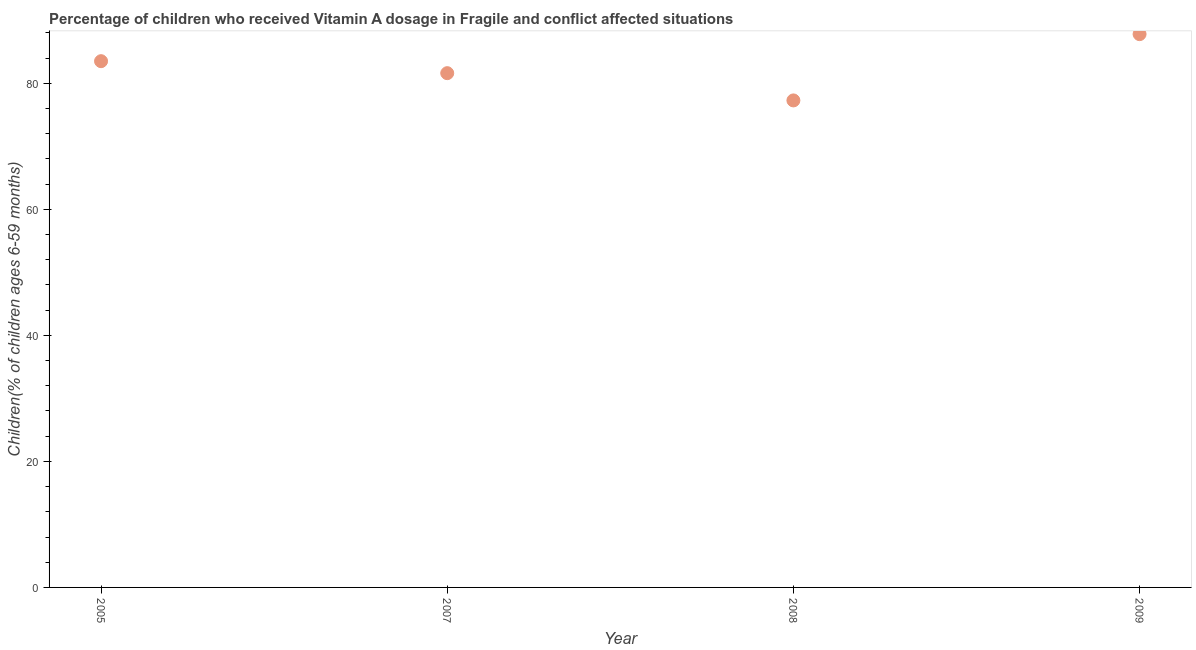What is the vitamin a supplementation coverage rate in 2005?
Offer a very short reply. 83.51. Across all years, what is the maximum vitamin a supplementation coverage rate?
Provide a short and direct response. 87.8. Across all years, what is the minimum vitamin a supplementation coverage rate?
Provide a succinct answer. 77.28. What is the sum of the vitamin a supplementation coverage rate?
Offer a very short reply. 330.21. What is the difference between the vitamin a supplementation coverage rate in 2005 and 2007?
Provide a short and direct response. 1.9. What is the average vitamin a supplementation coverage rate per year?
Give a very brief answer. 82.55. What is the median vitamin a supplementation coverage rate?
Keep it short and to the point. 82.56. In how many years, is the vitamin a supplementation coverage rate greater than 44 %?
Make the answer very short. 4. What is the ratio of the vitamin a supplementation coverage rate in 2005 to that in 2007?
Provide a succinct answer. 1.02. Is the vitamin a supplementation coverage rate in 2005 less than that in 2009?
Your response must be concise. Yes. What is the difference between the highest and the second highest vitamin a supplementation coverage rate?
Your response must be concise. 4.29. What is the difference between the highest and the lowest vitamin a supplementation coverage rate?
Your response must be concise. 10.52. In how many years, is the vitamin a supplementation coverage rate greater than the average vitamin a supplementation coverage rate taken over all years?
Your answer should be compact. 2. Does the graph contain grids?
Keep it short and to the point. No. What is the title of the graph?
Offer a very short reply. Percentage of children who received Vitamin A dosage in Fragile and conflict affected situations. What is the label or title of the Y-axis?
Offer a terse response. Children(% of children ages 6-59 months). What is the Children(% of children ages 6-59 months) in 2005?
Offer a terse response. 83.51. What is the Children(% of children ages 6-59 months) in 2007?
Offer a terse response. 81.61. What is the Children(% of children ages 6-59 months) in 2008?
Give a very brief answer. 77.28. What is the Children(% of children ages 6-59 months) in 2009?
Give a very brief answer. 87.8. What is the difference between the Children(% of children ages 6-59 months) in 2005 and 2007?
Make the answer very short. 1.9. What is the difference between the Children(% of children ages 6-59 months) in 2005 and 2008?
Ensure brevity in your answer.  6.23. What is the difference between the Children(% of children ages 6-59 months) in 2005 and 2009?
Provide a short and direct response. -4.29. What is the difference between the Children(% of children ages 6-59 months) in 2007 and 2008?
Provide a short and direct response. 4.33. What is the difference between the Children(% of children ages 6-59 months) in 2007 and 2009?
Keep it short and to the point. -6.19. What is the difference between the Children(% of children ages 6-59 months) in 2008 and 2009?
Offer a terse response. -10.52. What is the ratio of the Children(% of children ages 6-59 months) in 2005 to that in 2008?
Make the answer very short. 1.08. What is the ratio of the Children(% of children ages 6-59 months) in 2005 to that in 2009?
Ensure brevity in your answer.  0.95. What is the ratio of the Children(% of children ages 6-59 months) in 2007 to that in 2008?
Give a very brief answer. 1.06. What is the ratio of the Children(% of children ages 6-59 months) in 2007 to that in 2009?
Keep it short and to the point. 0.93. 